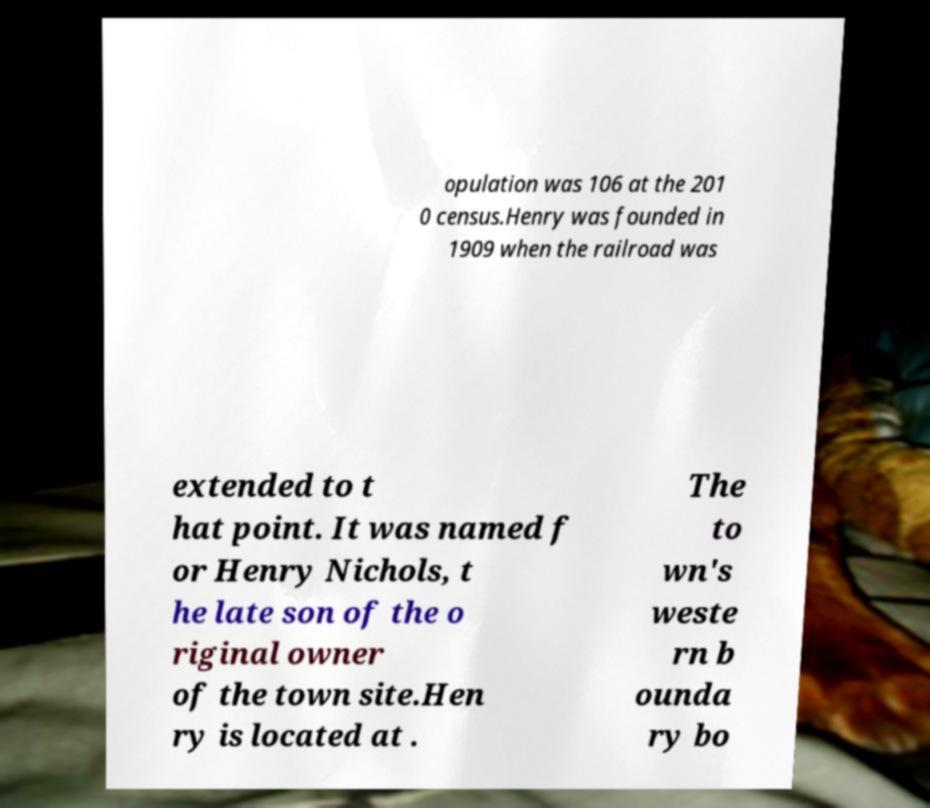Please identify and transcribe the text found in this image. opulation was 106 at the 201 0 census.Henry was founded in 1909 when the railroad was extended to t hat point. It was named f or Henry Nichols, t he late son of the o riginal owner of the town site.Hen ry is located at . The to wn's weste rn b ounda ry bo 